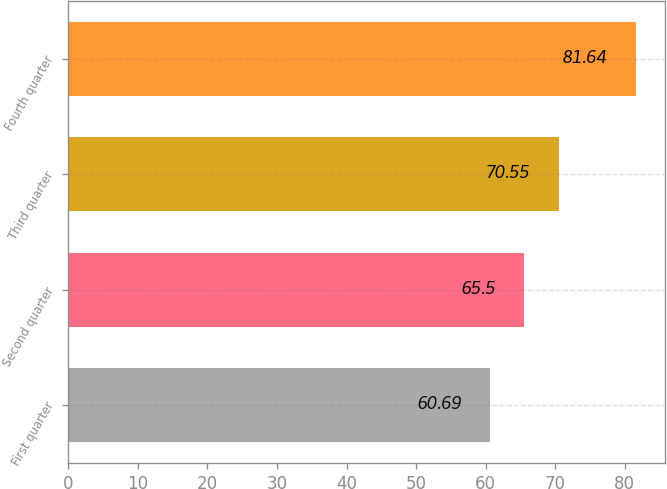<chart> <loc_0><loc_0><loc_500><loc_500><bar_chart><fcel>First quarter<fcel>Second quarter<fcel>Third quarter<fcel>Fourth quarter<nl><fcel>60.69<fcel>65.5<fcel>70.55<fcel>81.64<nl></chart> 